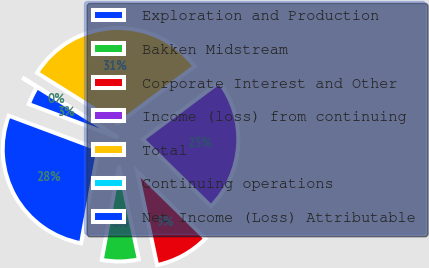Convert chart. <chart><loc_0><loc_0><loc_500><loc_500><pie_chart><fcel>Exploration and Production<fcel>Bakken Midstream<fcel>Corporate Interest and Other<fcel>Income (loss) from continuing<fcel>Total<fcel>Continuing operations<fcel>Net Income (Loss) Attributable<nl><fcel>27.8%<fcel>6.23%<fcel>9.31%<fcel>22.55%<fcel>30.88%<fcel>0.07%<fcel>3.15%<nl></chart> 